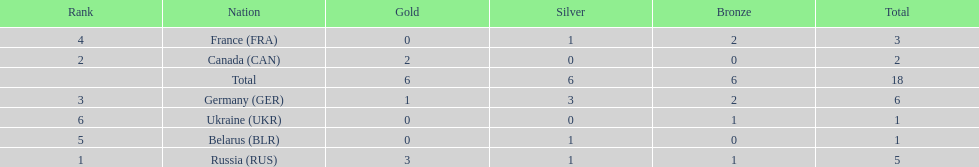What country had the most medals total at the the 1994 winter olympics biathlon? Germany (GER). 